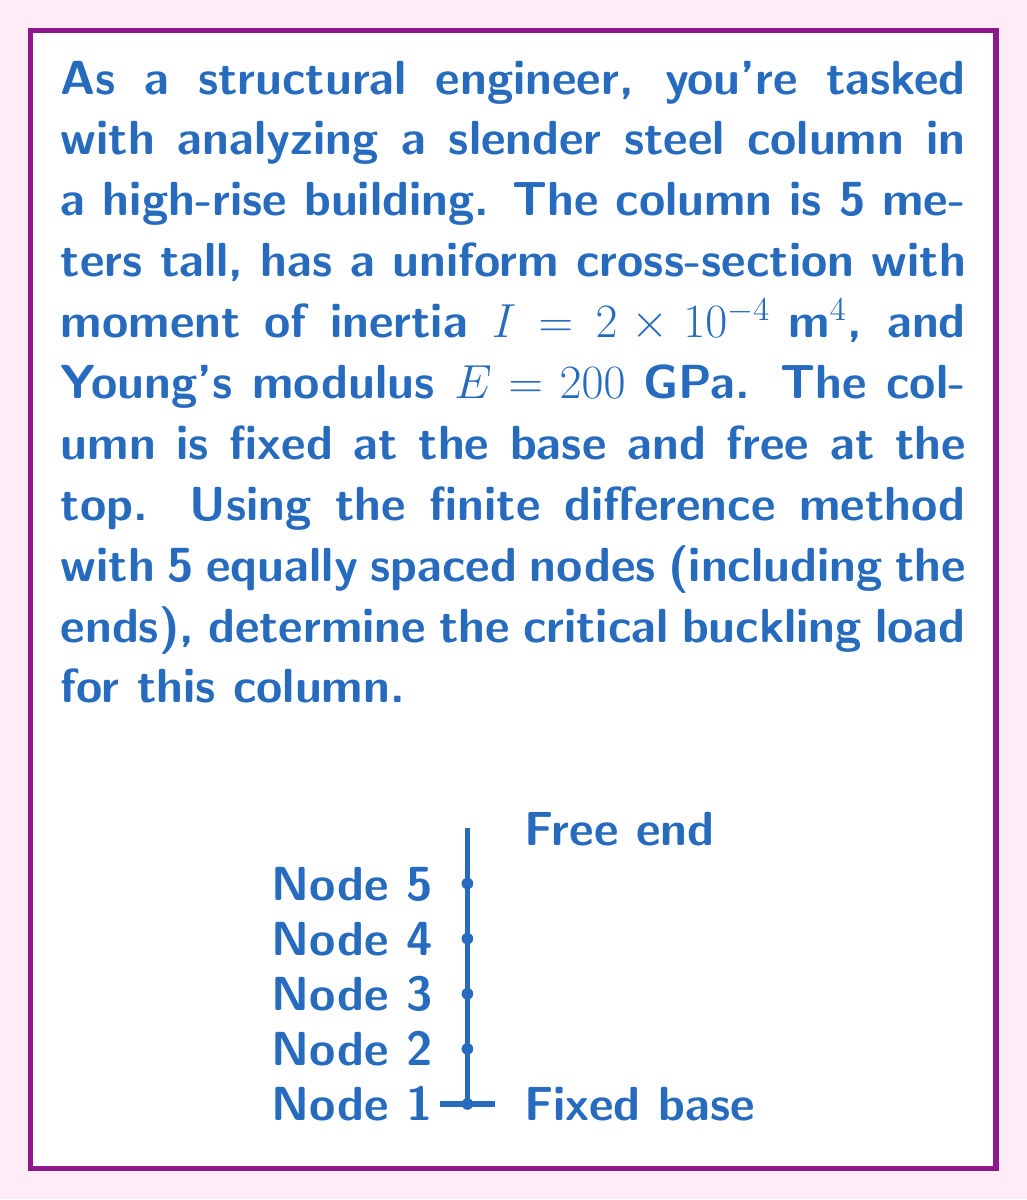Teach me how to tackle this problem. To solve this problem using the finite difference method, we'll follow these steps:

1) First, we need to set up the finite difference equation for the column. The governing differential equation for buckling is:

   $$\frac{d^2y}{dx^2} + k^2y = 0$$

   where $k^2 = \frac{P}{EI}$, and $P$ is the critical buckling load we're solving for.

2) Using central difference approximation for the second derivative:

   $$\frac{y_{i+1} - 2y_i + y_{i-1}}{h^2} + k^2y_i = 0$$

   where $h$ is the spacing between nodes.

3) With 5 nodes over 5 meters, $h = 1$ meter. We can set up the system of equations:

   Node 1 (base): $y_1 = 0$ (fixed)
   Node 2: $y_3 - 2y_2 + y_1 + k^2y_2 = 0$
   Node 3: $y_4 - 2y_3 + y_2 + k^2y_3 = 0$
   Node 4: $y_5 - 2y_4 + y_3 + k^2y_4 = 0$
   Node 5 (top): $y_4 - 2y_5 + y_3 + k^2y_5 = 0$ (free end condition)

4) Substituting $y_1 = 0$ and rearranging, we get the matrix equation:

   $$\begin{bmatrix}
   -2+k^2 & 1 & 0 & 0 \\
   1 & -2+k^2 & 1 & 0 \\
   0 & 1 & -2+k^2 & 1 \\
   0 & 1 & -1 & k^2
   \end{bmatrix}
   \begin{bmatrix}
   y_2 \\ y_3 \\ y_4 \\ y_5
   \end{bmatrix} = 
   \begin{bmatrix}
   0 \\ 0 \\ 0 \\ 0
   \end{bmatrix}$$

5) For a non-trivial solution, the determinant of the coefficient matrix must be zero. This gives us the characteristic equation:

   $$k^6 - 5k^4 + 4k^2 = 0$$

6) The smallest non-zero root of this equation is $k^2 \approx 2.4674$

7) Recall that $k^2 = \frac{P}{EI}$. Solving for $P$:

   $$P = k^2EI = 2.4674 \times 200 \times 10^9 \times 2 \times 10^{-4} = 98,696 \text{ N} \approx 98.7 \text{ kN}$$

Thus, the critical buckling load for the column is approximately 98.7 kN.
Answer: 98.7 kN 